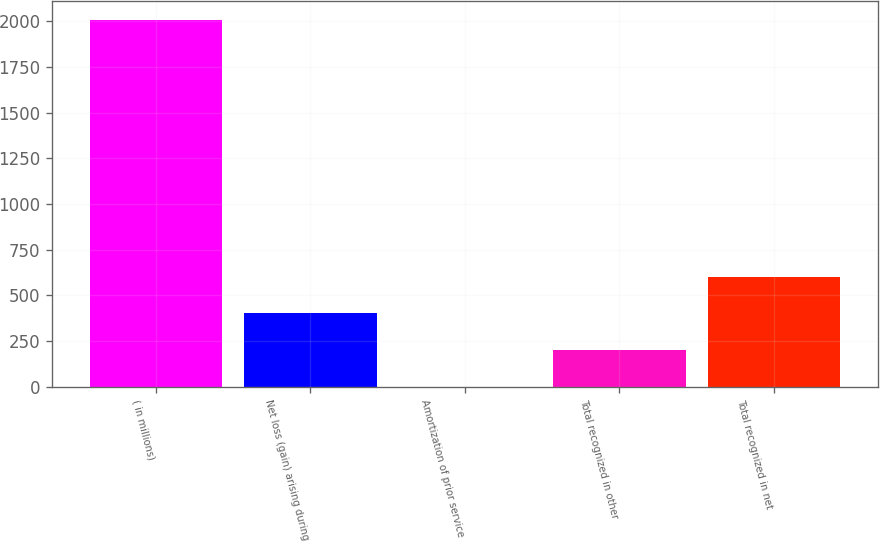Convert chart. <chart><loc_0><loc_0><loc_500><loc_500><bar_chart><fcel>( in millions)<fcel>Net loss (gain) arising during<fcel>Amortization of prior service<fcel>Total recognized in other<fcel>Total recognized in net<nl><fcel>2009<fcel>401.88<fcel>0.1<fcel>200.99<fcel>602.77<nl></chart> 